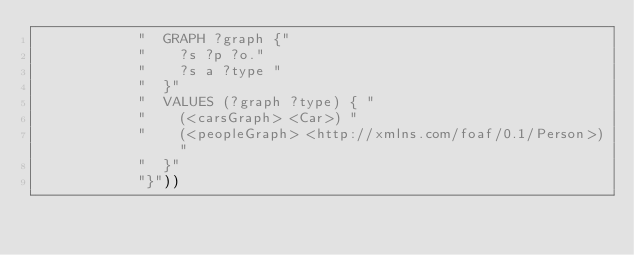<code> <loc_0><loc_0><loc_500><loc_500><_Scheme_>            "  GRAPH ?graph {"
            "    ?s ?p ?o."
            "    ?s a ?type "
            "  }"
            "  VALUES (?graph ?type) { "
            "    (<carsGraph> <Car>) "
            "    (<peopleGraph> <http://xmlns.com/foaf/0.1/Person>) "
            "  }"
            "}"))
</code> 